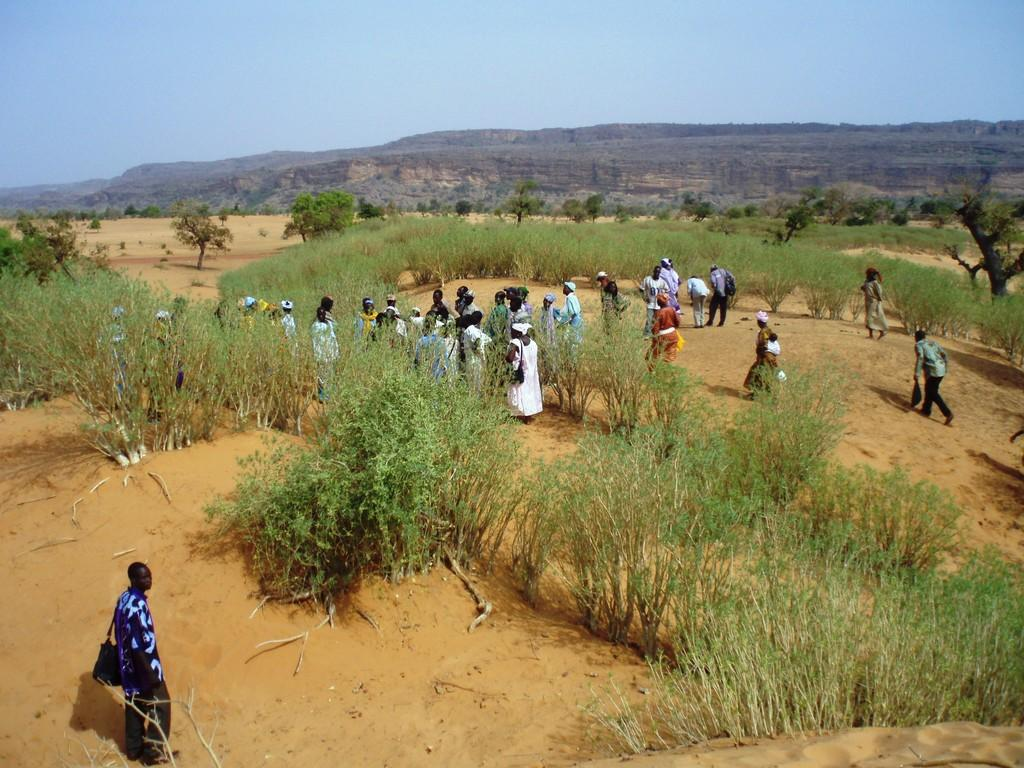How many people are in the image? There is a group of people in the image. What are the people in the image doing? Some people are standing, while others are walking. What can be seen on the ground in the image? The ground is visible in the image. What type of vegetation is present in the image? There are trees in the image. What is visible in the background of the image? There are mountains and the sky visible in the background of the image. What type of art can be seen on the back of the vase in the image? There is no vase present in the image, and therefore no art can be seen on its back. 